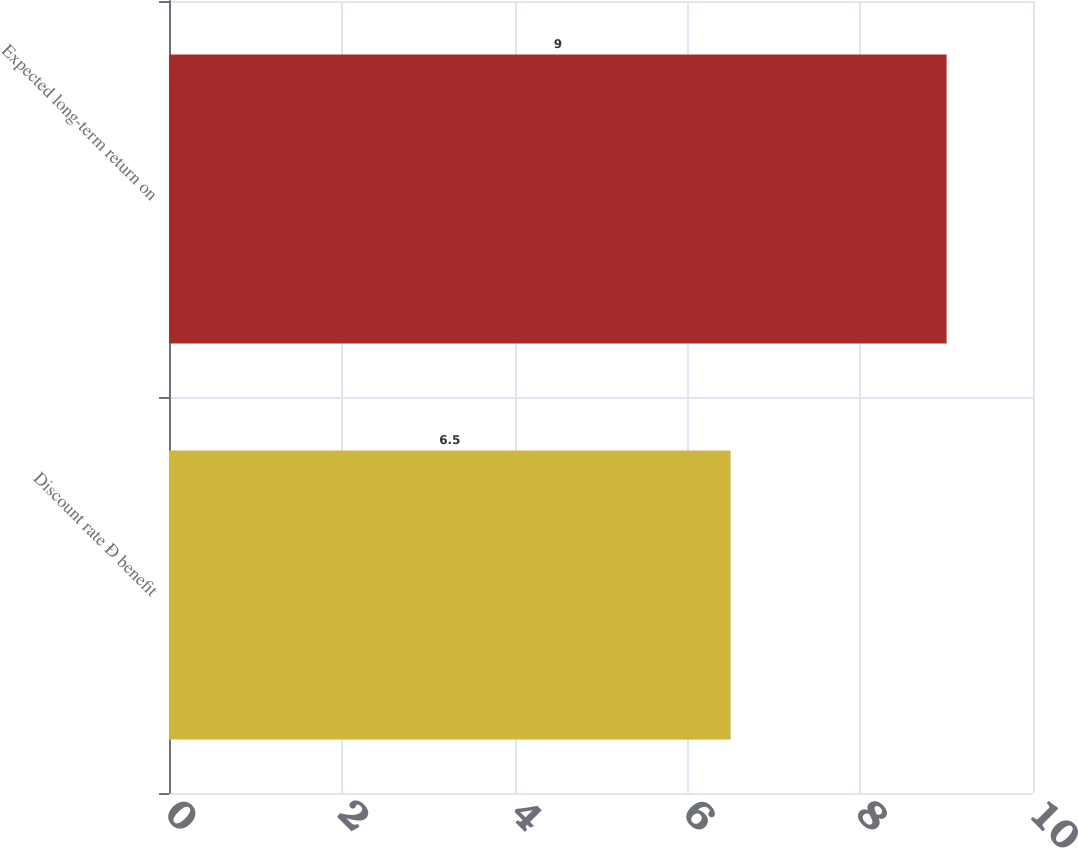<chart> <loc_0><loc_0><loc_500><loc_500><bar_chart><fcel>Discount rate Ð benefit<fcel>Expected long-term return on<nl><fcel>6.5<fcel>9<nl></chart> 